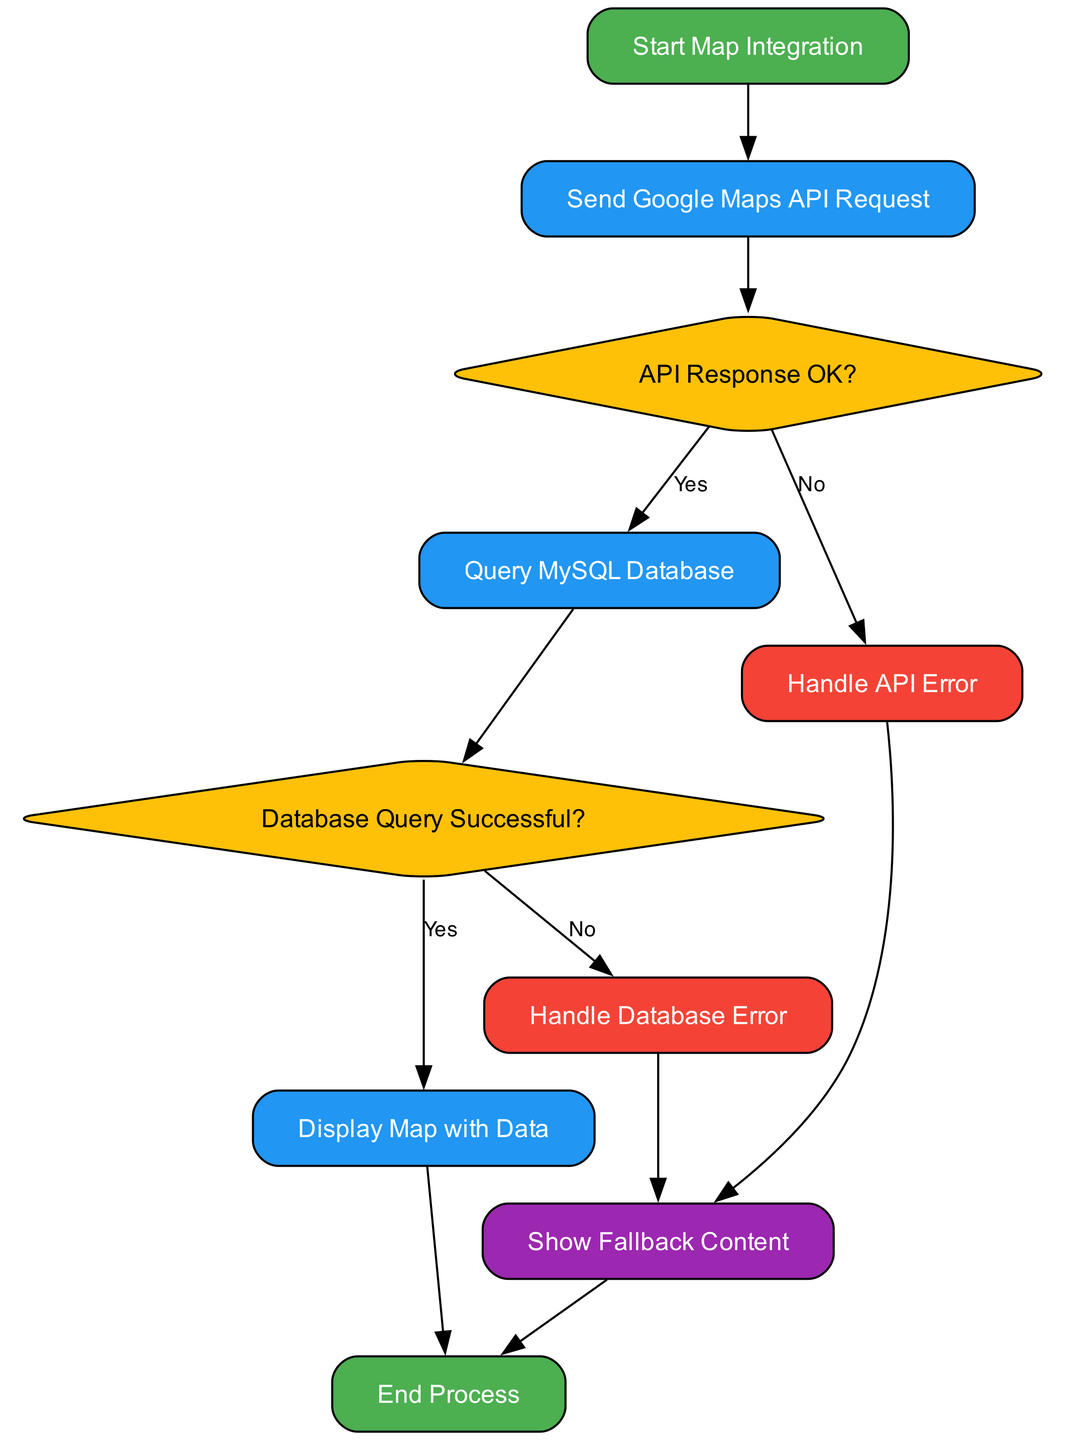What is the first step in the flowchart? The first node in the flowchart is labeled "Start Map Integration," which indicates the initial step in the process.
Answer: Start Map Integration How many nodes are in the diagram? Counting all the unique nodes in the flowchart gives us a total of ten nodes, including decisions and process steps.
Answer: 10 What happens if the API response is not OK? If the API response is not OK, the flowchart indicates that we move to the "Handle API Error" node to manage the situation.
Answer: Handle API Error What is the result if the database query is successful? When the database query is successful, the flowchart leads to the "Display Map with Data" node, indicating successful integration and display.
Answer: Display Map with Data What does the flowchart indicate to show in case of errors? In case of either an API error or a database error, the flowchart specifies to "Show Fallback Content" as an alternative to provide content when issues arise.
Answer: Show Fallback Content What is the last step in the flowchart? The final node in the flowchart, reached from either the display map or fallback content, is the "End Process," indicating completion of the entire integration workflow.
Answer: End Process Which node acts as a decision point concerning the API? The node labeled "API Response OK?" serves as a decision point in the flowchart regarding the outcome of the API request.
Answer: API Response OK? What is the fallback content used for in the diagram? The fallback content is utilized in the event of errors during API handling or database queries, ensuring users still receive some form of content.
Answer: Show Fallback Content How is the database query checked for success? The flowchart indicates that after querying the database, it moves to "Database Query Successful?" to check whether the query executed properly.
Answer: Database Query Successful? 